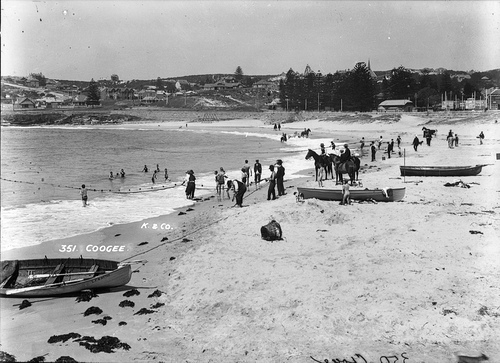Identify the text displayed in this image. GOOGLE 351 A CO- 320 